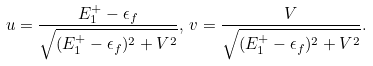<formula> <loc_0><loc_0><loc_500><loc_500>u = \frac { E _ { 1 } ^ { + } - \epsilon _ { f } } { \sqrt { ( E _ { 1 } ^ { + } - \epsilon _ { f } ) ^ { 2 } + V ^ { 2 } } } , \, v = \frac { V } { \sqrt { ( E _ { 1 } ^ { + } - \epsilon _ { f } ) ^ { 2 } + V ^ { 2 } } } . \\</formula> 